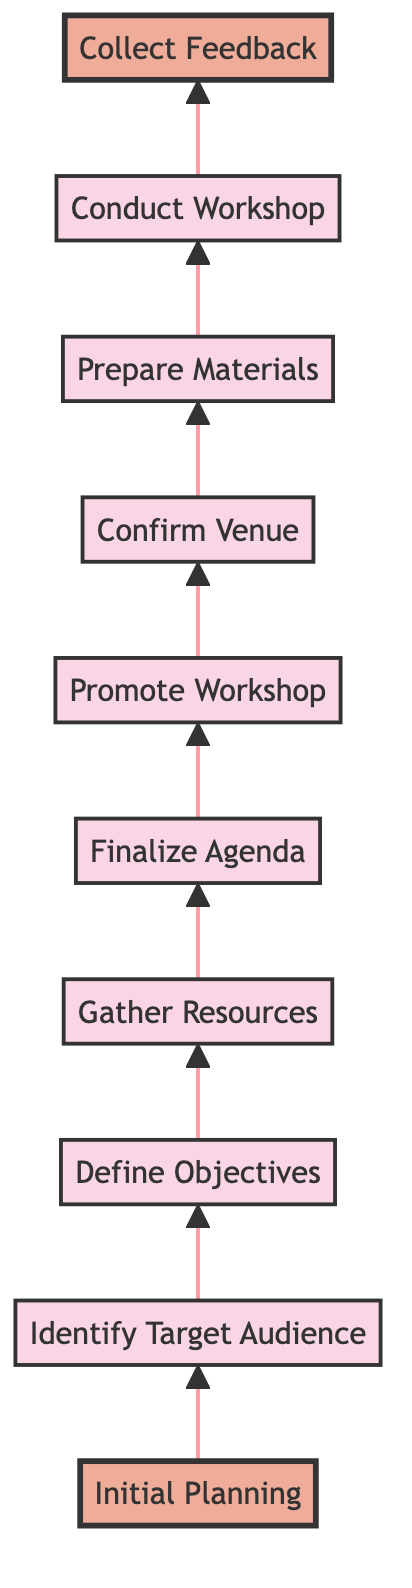What is the first step in organizing a local feminist workshop? The first step is "Initial Planning," which involves setting dates, creating a rough plan, and identifying potential challenges. This is visualized as the bottom-most node in the flowchart.
Answer: Initial Planning How many steps are there in the flowchart? There are ten steps in the flowchart, counting from the "Initial Planning" node up to the "Collect Feedback" node. Each step represents a part of the workshop organizing process.
Answer: Ten Which step comes after "Gather Resources"? The step that comes after "Gather Resources" is "Finalize Agenda." This can be determined by following the flow from the "Gather Resources" node upwards to the next node in the sequence.
Answer: Finalize Agenda What is the last step in the process? The last step in the process is "Collect Feedback," which is at the top of the flowchart. It signifies the conclusion of the workshop organization and an assessment of its impact.
Answer: Collect Feedback What are the objectives of the workshop defined before gathering resources? The objectives of the workshop, defined in the "Define Objectives" step, focus on gender equality, women's empowerment, and community building. This is established as one of the crucial foundational steps in the planning process.
Answer: Gender equality, women's empowerment, and community building Which two steps directly follow "Promote Workshop"? The two steps that directly follow "Promote Workshop" are "Confirm Venue" and then "Prepare Materials." This sequence can be traced by looking at the flow from the "Promote Workshop" node upward.
Answer: Confirm Venue and Prepare Materials What is the purpose of the "Conduct Workshop" step? The purpose of the "Conduct Workshop" step is to execute the planned workshop as per the schedule, ensuring active participation and inclusive discussions among attendees. This node summarizes the main activity of the organization process.
Answer: Conduct the workshop What requires preparation before the workshop is conducted? Before the workshop is conducted, "Prepare Materials" must be completed. This node specifies the preparation of essential materials like presentations and handouts which supports the workshop's objectives.
Answer: Prepare Materials Which node highlights the final outcome of the entire process? The node that highlights the final outcome of the entire process is "Collect Feedback." This is the last step, focused on evaluating the success and areas for improvement based on participant responses.
Answer: Collect Feedback 